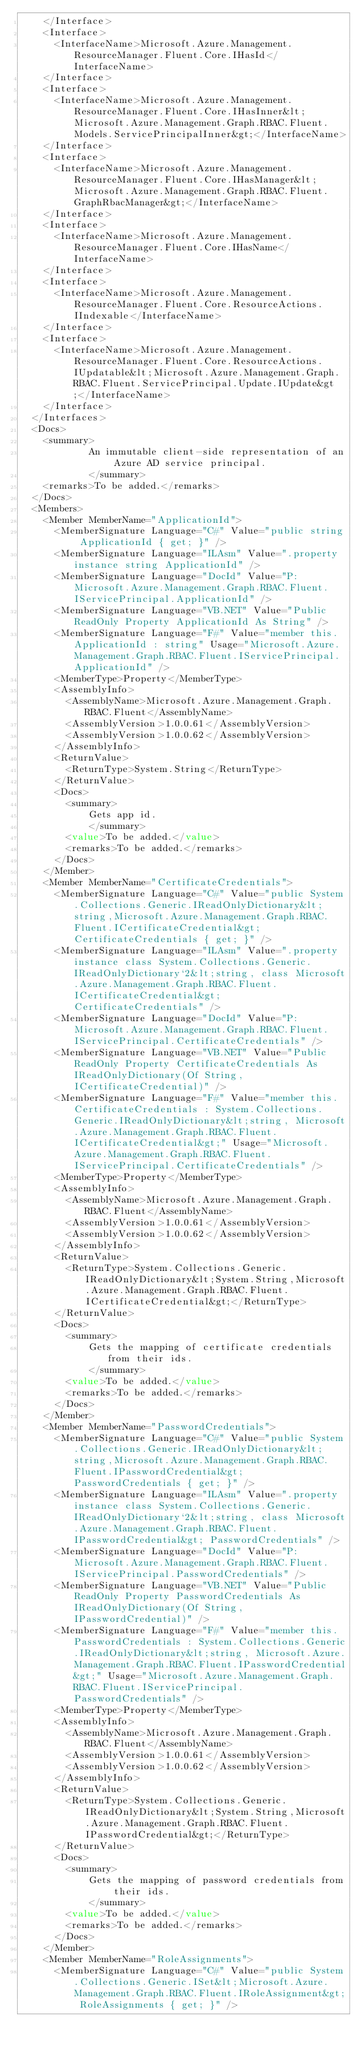Convert code to text. <code><loc_0><loc_0><loc_500><loc_500><_XML_>    </Interface>
    <Interface>
      <InterfaceName>Microsoft.Azure.Management.ResourceManager.Fluent.Core.IHasId</InterfaceName>
    </Interface>
    <Interface>
      <InterfaceName>Microsoft.Azure.Management.ResourceManager.Fluent.Core.IHasInner&lt;Microsoft.Azure.Management.Graph.RBAC.Fluent.Models.ServicePrincipalInner&gt;</InterfaceName>
    </Interface>
    <Interface>
      <InterfaceName>Microsoft.Azure.Management.ResourceManager.Fluent.Core.IHasManager&lt;Microsoft.Azure.Management.Graph.RBAC.Fluent.GraphRbacManager&gt;</InterfaceName>
    </Interface>
    <Interface>
      <InterfaceName>Microsoft.Azure.Management.ResourceManager.Fluent.Core.IHasName</InterfaceName>
    </Interface>
    <Interface>
      <InterfaceName>Microsoft.Azure.Management.ResourceManager.Fluent.Core.ResourceActions.IIndexable</InterfaceName>
    </Interface>
    <Interface>
      <InterfaceName>Microsoft.Azure.Management.ResourceManager.Fluent.Core.ResourceActions.IUpdatable&lt;Microsoft.Azure.Management.Graph.RBAC.Fluent.ServicePrincipal.Update.IUpdate&gt;</InterfaceName>
    </Interface>
  </Interfaces>
  <Docs>
    <summary>
            An immutable client-side representation of an Azure AD service principal.
            </summary>
    <remarks>To be added.</remarks>
  </Docs>
  <Members>
    <Member MemberName="ApplicationId">
      <MemberSignature Language="C#" Value="public string ApplicationId { get; }" />
      <MemberSignature Language="ILAsm" Value=".property instance string ApplicationId" />
      <MemberSignature Language="DocId" Value="P:Microsoft.Azure.Management.Graph.RBAC.Fluent.IServicePrincipal.ApplicationId" />
      <MemberSignature Language="VB.NET" Value="Public ReadOnly Property ApplicationId As String" />
      <MemberSignature Language="F#" Value="member this.ApplicationId : string" Usage="Microsoft.Azure.Management.Graph.RBAC.Fluent.IServicePrincipal.ApplicationId" />
      <MemberType>Property</MemberType>
      <AssemblyInfo>
        <AssemblyName>Microsoft.Azure.Management.Graph.RBAC.Fluent</AssemblyName>
        <AssemblyVersion>1.0.0.61</AssemblyVersion>
        <AssemblyVersion>1.0.0.62</AssemblyVersion>
      </AssemblyInfo>
      <ReturnValue>
        <ReturnType>System.String</ReturnType>
      </ReturnValue>
      <Docs>
        <summary>
            Gets app id.
            </summary>
        <value>To be added.</value>
        <remarks>To be added.</remarks>
      </Docs>
    </Member>
    <Member MemberName="CertificateCredentials">
      <MemberSignature Language="C#" Value="public System.Collections.Generic.IReadOnlyDictionary&lt;string,Microsoft.Azure.Management.Graph.RBAC.Fluent.ICertificateCredential&gt; CertificateCredentials { get; }" />
      <MemberSignature Language="ILAsm" Value=".property instance class System.Collections.Generic.IReadOnlyDictionary`2&lt;string, class Microsoft.Azure.Management.Graph.RBAC.Fluent.ICertificateCredential&gt; CertificateCredentials" />
      <MemberSignature Language="DocId" Value="P:Microsoft.Azure.Management.Graph.RBAC.Fluent.IServicePrincipal.CertificateCredentials" />
      <MemberSignature Language="VB.NET" Value="Public ReadOnly Property CertificateCredentials As IReadOnlyDictionary(Of String, ICertificateCredential)" />
      <MemberSignature Language="F#" Value="member this.CertificateCredentials : System.Collections.Generic.IReadOnlyDictionary&lt;string, Microsoft.Azure.Management.Graph.RBAC.Fluent.ICertificateCredential&gt;" Usage="Microsoft.Azure.Management.Graph.RBAC.Fluent.IServicePrincipal.CertificateCredentials" />
      <MemberType>Property</MemberType>
      <AssemblyInfo>
        <AssemblyName>Microsoft.Azure.Management.Graph.RBAC.Fluent</AssemblyName>
        <AssemblyVersion>1.0.0.61</AssemblyVersion>
        <AssemblyVersion>1.0.0.62</AssemblyVersion>
      </AssemblyInfo>
      <ReturnValue>
        <ReturnType>System.Collections.Generic.IReadOnlyDictionary&lt;System.String,Microsoft.Azure.Management.Graph.RBAC.Fluent.ICertificateCredential&gt;</ReturnType>
      </ReturnValue>
      <Docs>
        <summary>
            Gets the mapping of certificate credentials from their ids.
            </summary>
        <value>To be added.</value>
        <remarks>To be added.</remarks>
      </Docs>
    </Member>
    <Member MemberName="PasswordCredentials">
      <MemberSignature Language="C#" Value="public System.Collections.Generic.IReadOnlyDictionary&lt;string,Microsoft.Azure.Management.Graph.RBAC.Fluent.IPasswordCredential&gt; PasswordCredentials { get; }" />
      <MemberSignature Language="ILAsm" Value=".property instance class System.Collections.Generic.IReadOnlyDictionary`2&lt;string, class Microsoft.Azure.Management.Graph.RBAC.Fluent.IPasswordCredential&gt; PasswordCredentials" />
      <MemberSignature Language="DocId" Value="P:Microsoft.Azure.Management.Graph.RBAC.Fluent.IServicePrincipal.PasswordCredentials" />
      <MemberSignature Language="VB.NET" Value="Public ReadOnly Property PasswordCredentials As IReadOnlyDictionary(Of String, IPasswordCredential)" />
      <MemberSignature Language="F#" Value="member this.PasswordCredentials : System.Collections.Generic.IReadOnlyDictionary&lt;string, Microsoft.Azure.Management.Graph.RBAC.Fluent.IPasswordCredential&gt;" Usage="Microsoft.Azure.Management.Graph.RBAC.Fluent.IServicePrincipal.PasswordCredentials" />
      <MemberType>Property</MemberType>
      <AssemblyInfo>
        <AssemblyName>Microsoft.Azure.Management.Graph.RBAC.Fluent</AssemblyName>
        <AssemblyVersion>1.0.0.61</AssemblyVersion>
        <AssemblyVersion>1.0.0.62</AssemblyVersion>
      </AssemblyInfo>
      <ReturnValue>
        <ReturnType>System.Collections.Generic.IReadOnlyDictionary&lt;System.String,Microsoft.Azure.Management.Graph.RBAC.Fluent.IPasswordCredential&gt;</ReturnType>
      </ReturnValue>
      <Docs>
        <summary>
            Gets the mapping of password credentials from their ids.
            </summary>
        <value>To be added.</value>
        <remarks>To be added.</remarks>
      </Docs>
    </Member>
    <Member MemberName="RoleAssignments">
      <MemberSignature Language="C#" Value="public System.Collections.Generic.ISet&lt;Microsoft.Azure.Management.Graph.RBAC.Fluent.IRoleAssignment&gt; RoleAssignments { get; }" /></code> 